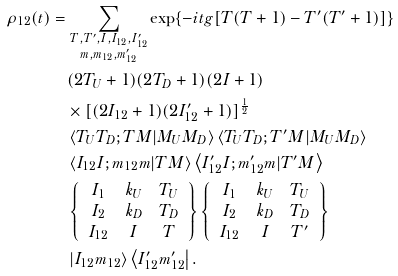<formula> <loc_0><loc_0><loc_500><loc_500>\rho _ { 1 2 } ( t ) & = \sum _ { \substack { T , T ^ { \prime } , I , I _ { 1 2 } , I ^ { \prime } _ { 1 2 } \\ m , m _ { 1 2 } , m ^ { \prime } _ { 1 2 } } } \exp \{ - i t g [ T ( T + 1 ) - T ^ { \prime } ( T ^ { \prime } + 1 ) ] \} \\ & \quad ( 2 T _ { U } + 1 ) ( 2 T _ { D } + 1 ) ( 2 I + 1 ) \\ & \quad \times [ ( 2 I _ { 1 2 } + 1 ) ( 2 I ^ { \prime } _ { 1 2 } + 1 ) ] ^ { \frac { 1 } { 2 } } \\ & \quad \left \langle T _ { U } T _ { D } ; T M | M _ { U } M _ { D } \right \rangle \left \langle T _ { U } T _ { D } ; T ^ { \prime } M | M _ { U } M _ { D } \right \rangle \\ & \quad \left \langle I _ { 1 2 } I ; m _ { 1 2 } m | T M \right \rangle \left \langle I ^ { \prime } _ { 1 2 } I ; m ^ { \prime } _ { 1 2 } m | T ^ { \prime } M \right \rangle \\ & \quad \left \{ \begin{array} { c c c } I _ { 1 } & k _ { U } & T _ { U } \\ I _ { 2 } & k _ { D } & T _ { D } \\ I _ { 1 2 } & I & T \\ \end{array} \right \} \left \{ \begin{array} { c c c } I _ { 1 } & k _ { U } & T _ { U } \\ I _ { 2 } & k _ { D } & T _ { D } \\ I _ { 1 2 } & I & T ^ { \prime } \\ \end{array} \right \} \\ & \quad \left | I _ { 1 2 } m _ { 1 2 } \right \rangle \left \langle I ^ { \prime } _ { 1 2 } m ^ { \prime } _ { 1 2 } \right | . \\</formula> 